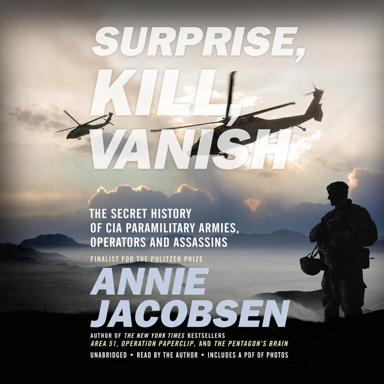What achievement is this book known for? Annie Jacobsen's book "Surprise, Kill, Vanish" was notably honored as a finalist for the Pulitzer Prize, recognizing its compelling narrative and detailed research into covert CIA operations. 